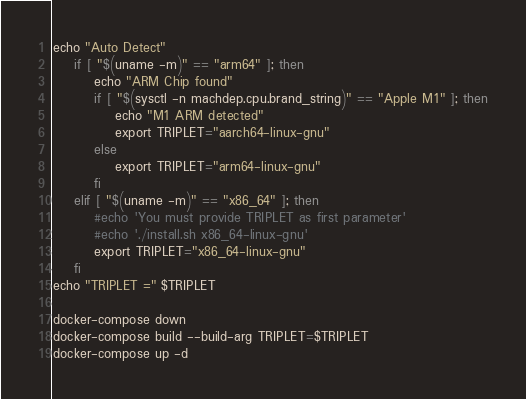<code> <loc_0><loc_0><loc_500><loc_500><_Bash_>echo "Auto Detect"
    if [ "$(uname -m)" == "arm64" ]; then
        echo "ARM Chip found"
        if [ "$(sysctl -n machdep.cpu.brand_string)" == "Apple M1" ]; then
            echo "M1 ARM detected"
            export TRIPLET="aarch64-linux-gnu"
        else
            export TRIPLET="arm64-linux-gnu"
        fi
    elif [ "$(uname -m)" == "x86_64" ]; then
        #echo 'You must provide TRIPLET as first parameter'
        #echo './install.sh x86_64-linux-gnu'
        export TRIPLET="x86_64-linux-gnu"
    fi
echo "TRIPLET =" $TRIPLET

docker-compose down
docker-compose build --build-arg TRIPLET=$TRIPLET
docker-compose up -d</code> 